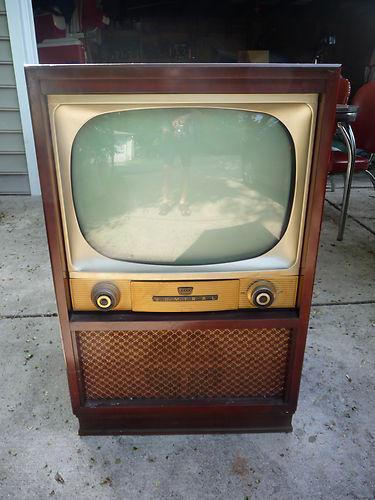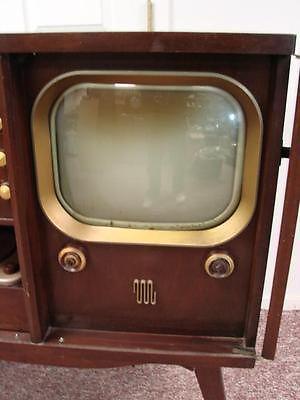The first image is the image on the left, the second image is the image on the right. Considering the images on both sides, is "Each of two older television sets is in a wooden case with a gold tone rim around the picture tube, and two or four control knobs underneath." valid? Answer yes or no. Yes. The first image is the image on the left, the second image is the image on the right. Given the left and right images, does the statement "At least one image shows a TV screen that is flat on the top and bottom, and curved on the sides." hold true? Answer yes or no. No. 